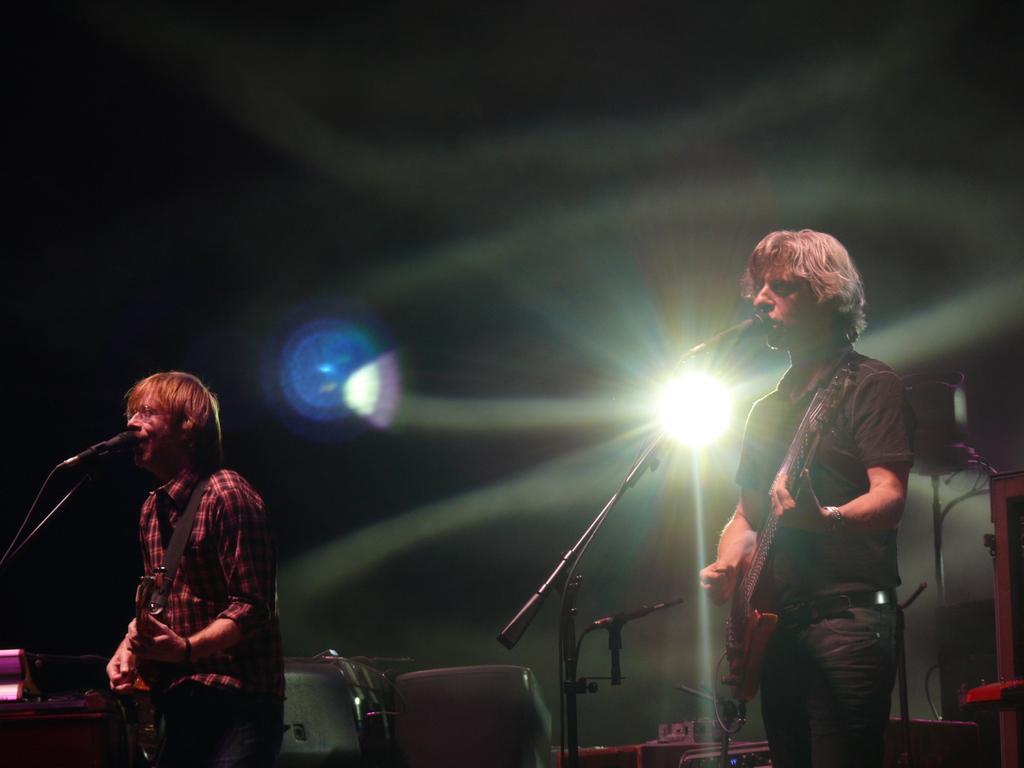Describe this image in one or two sentences. In this image i can see there are two persons standing on the floor and holding a guitar and stand in front of a mike and background there is light visible. 